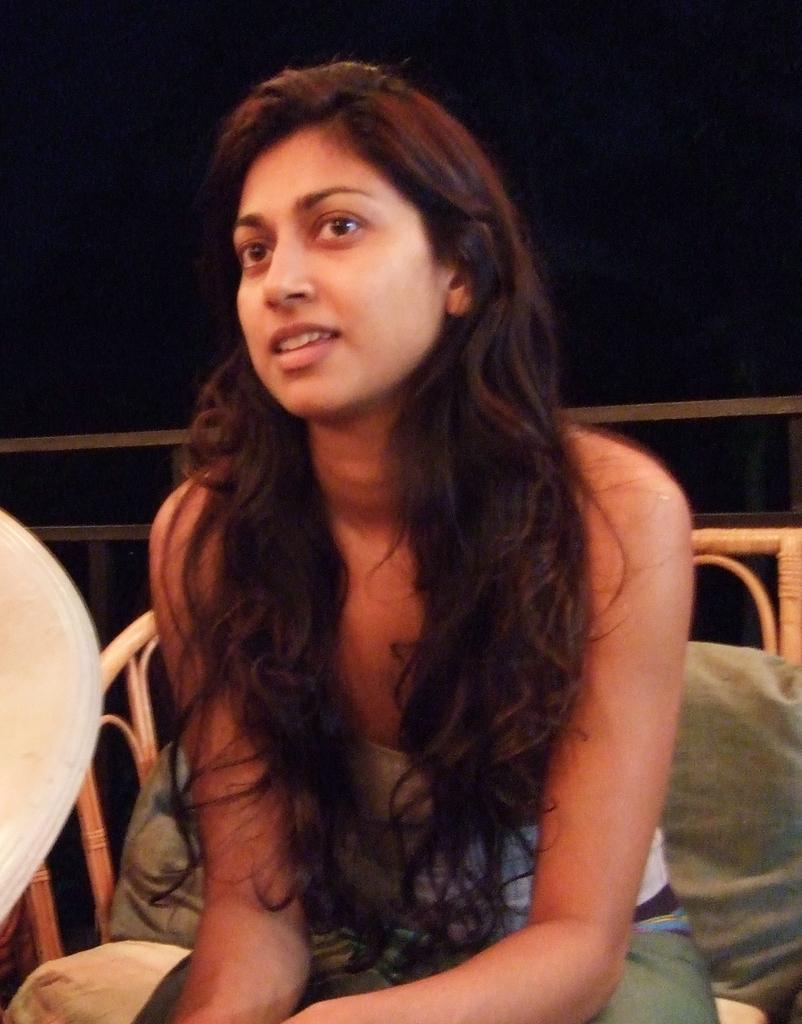Who is the main subject in the image? There is a lady in the image. What is the lady doing in the image? The lady is sitting on a sofa. Can you describe the background of the image? The background of the image is dark. What other object can be seen in the image? There is a railing in the image. What type of berry is the lady attempting to pick from the railing in the image? There is no berry present in the image, nor is the lady attempting to pick anything from the railing. 